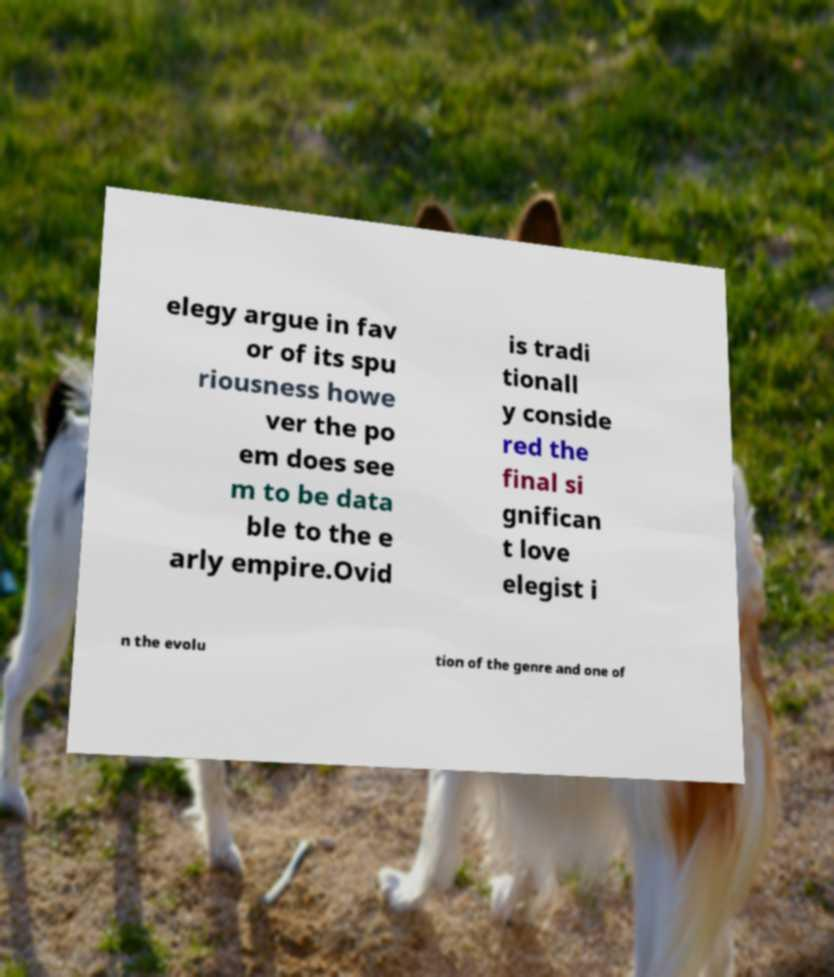Please identify and transcribe the text found in this image. elegy argue in fav or of its spu riousness howe ver the po em does see m to be data ble to the e arly empire.Ovid is tradi tionall y conside red the final si gnifican t love elegist i n the evolu tion of the genre and one of 